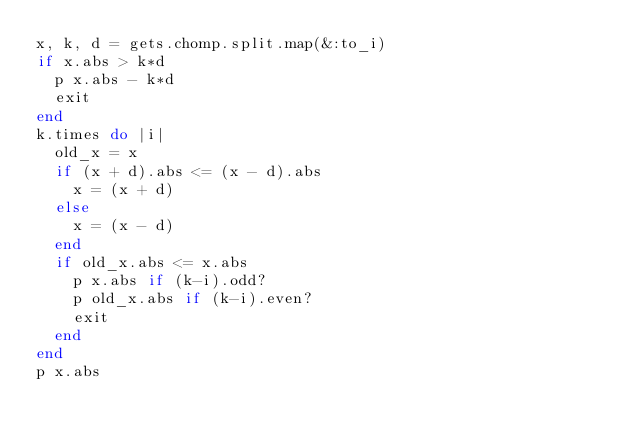Convert code to text. <code><loc_0><loc_0><loc_500><loc_500><_Ruby_>x, k, d = gets.chomp.split.map(&:to_i)
if x.abs > k*d
  p x.abs - k*d
  exit
end
k.times do |i|
  old_x = x
  if (x + d).abs <= (x - d).abs
    x = (x + d)
  else
    x = (x - d)
  end
  if old_x.abs <= x.abs
    p x.abs if (k-i).odd?
    p old_x.abs if (k-i).even?
    exit
  end
end
p x.abs</code> 